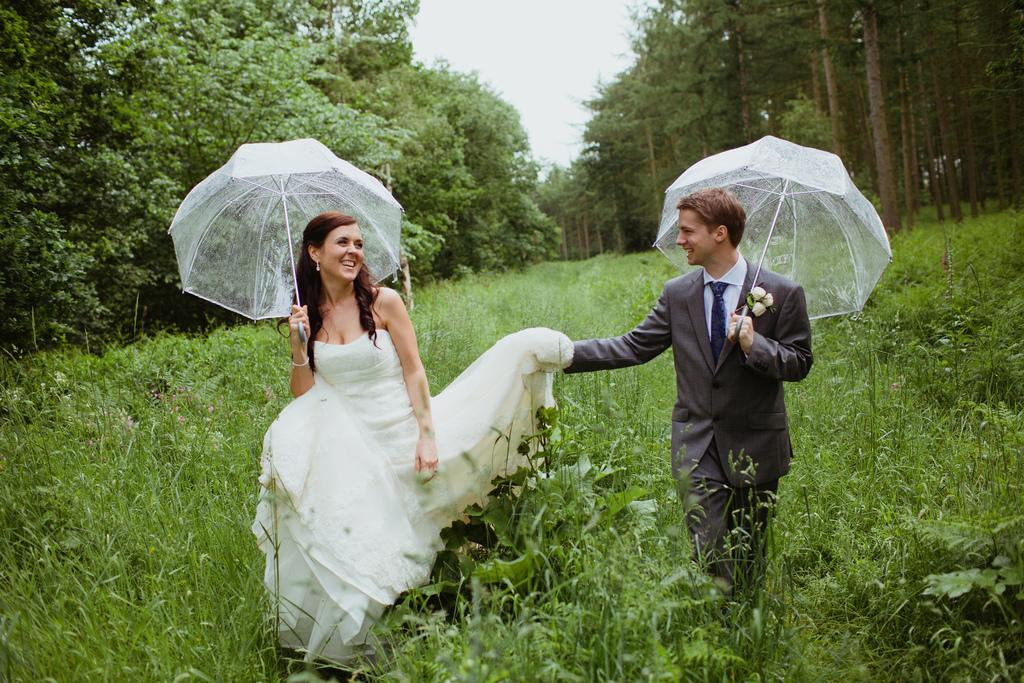How many people are present in the image? There are two people, a man and a woman, present in the image. What are the man and woman doing in the image? The man and woman are holding an umbrella in the image. What expressions do the man and woman have in the image? The man and woman are smiling in the image. What can be seen in the background of the image? There are plants and trees in the background of the image. Reasoning: Let'ing: Let's think step by step in order to produce the conversation. We start by identifying the main subjects in the image, which are the man and woman. Then, we describe their actions and expressions, noting that they are holding an umbrella and smiling. Finally, we describe the background of the image, which includes plants and trees. Absurd Question/Answer: What type of knowledge is the man sharing with the woman in the image? There is no indication in the image that the man is sharing any knowledge with the woman. What type of hose is visible in the image? There is no hose present in the image. 